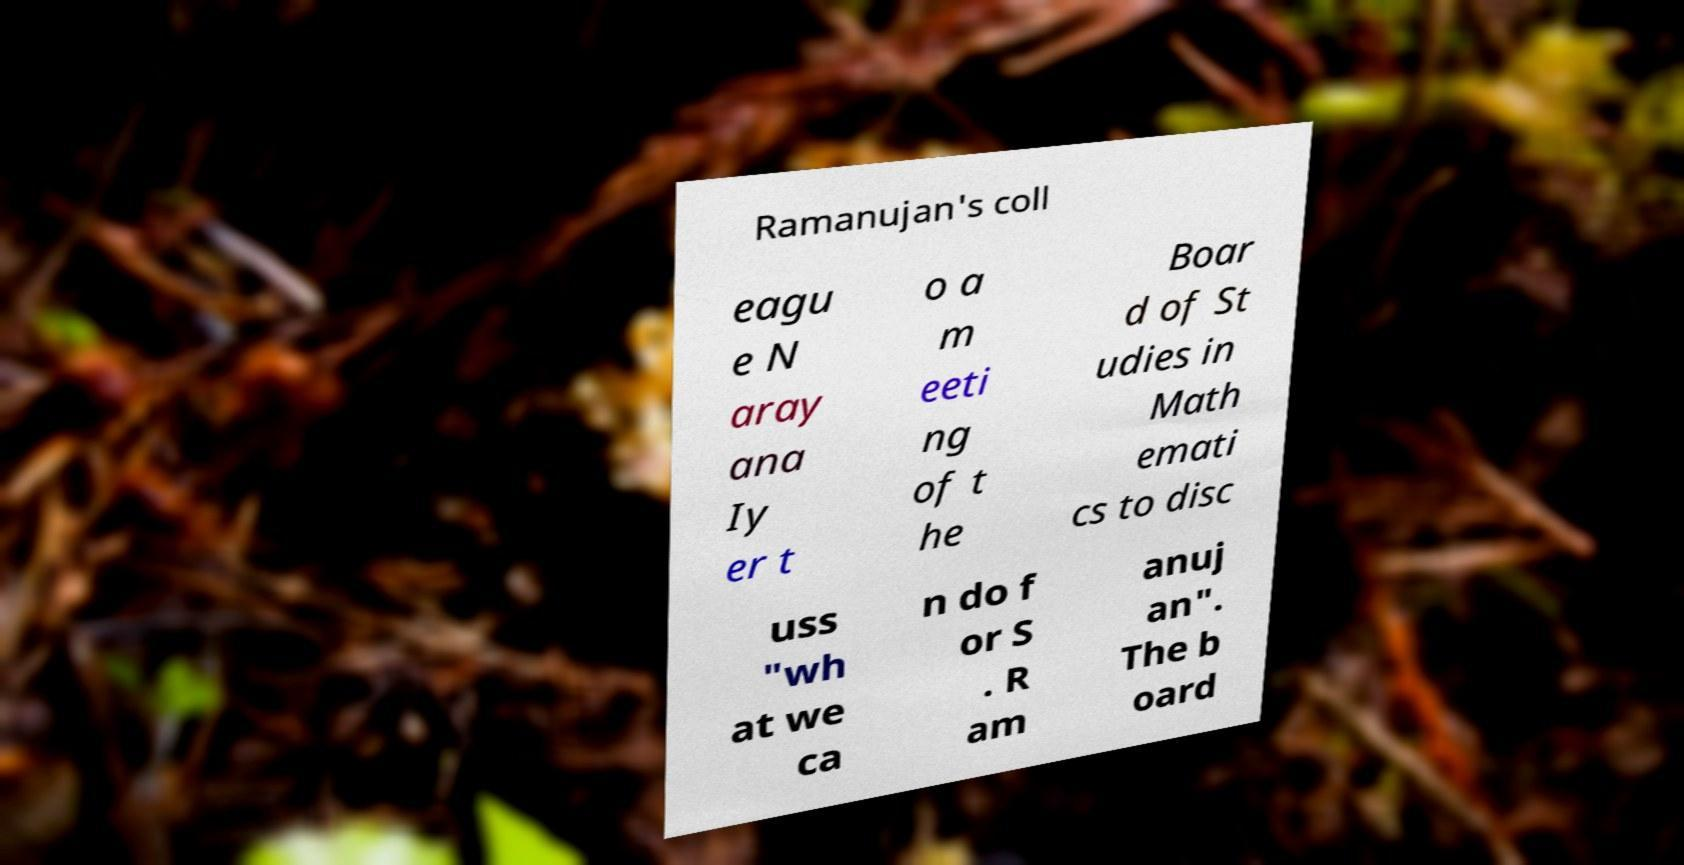Can you accurately transcribe the text from the provided image for me? Ramanujan's coll eagu e N aray ana Iy er t o a m eeti ng of t he Boar d of St udies in Math emati cs to disc uss "wh at we ca n do f or S . R am anuj an". The b oard 